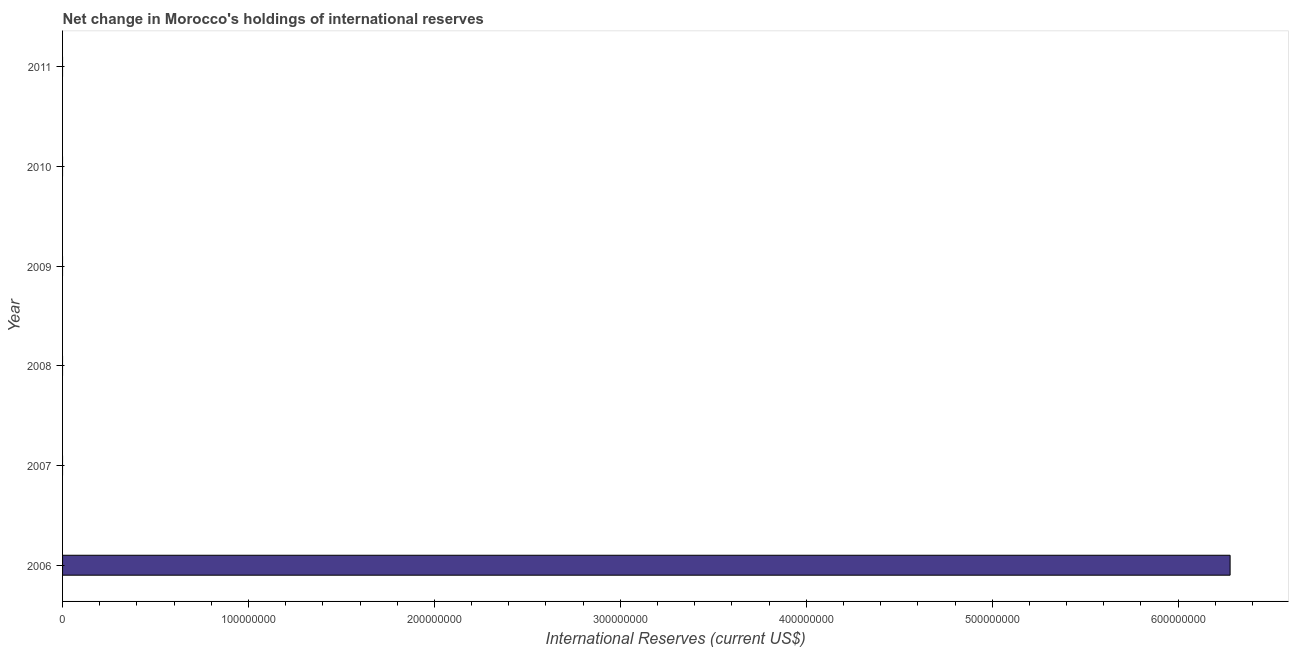Does the graph contain any zero values?
Your answer should be very brief. Yes. Does the graph contain grids?
Offer a very short reply. No. What is the title of the graph?
Give a very brief answer. Net change in Morocco's holdings of international reserves. What is the label or title of the X-axis?
Provide a short and direct response. International Reserves (current US$). Across all years, what is the maximum reserves and related items?
Your answer should be very brief. 6.28e+08. Across all years, what is the minimum reserves and related items?
Provide a succinct answer. 0. What is the sum of the reserves and related items?
Give a very brief answer. 6.28e+08. What is the average reserves and related items per year?
Ensure brevity in your answer.  1.05e+08. What is the median reserves and related items?
Make the answer very short. 0. In how many years, is the reserves and related items greater than 20000000 US$?
Provide a succinct answer. 1. What is the difference between the highest and the lowest reserves and related items?
Offer a very short reply. 6.28e+08. In how many years, is the reserves and related items greater than the average reserves and related items taken over all years?
Provide a succinct answer. 1. How many bars are there?
Give a very brief answer. 1. What is the difference between two consecutive major ticks on the X-axis?
Provide a succinct answer. 1.00e+08. What is the International Reserves (current US$) of 2006?
Keep it short and to the point. 6.28e+08. What is the International Reserves (current US$) in 2009?
Your response must be concise. 0. What is the International Reserves (current US$) of 2010?
Make the answer very short. 0. 